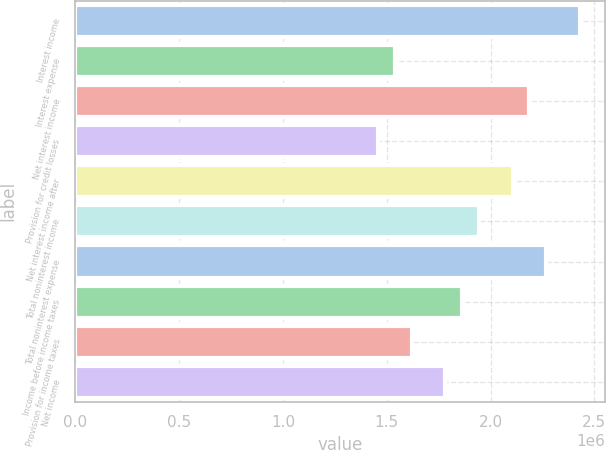Convert chart to OTSL. <chart><loc_0><loc_0><loc_500><loc_500><bar_chart><fcel>Interest income<fcel>Interest expense<fcel>Net interest income<fcel>Provision for credit losses<fcel>Net interest income after<fcel>Total noninterest income<fcel>Total noninterest expense<fcel>Income before income taxes<fcel>Provision for income taxes<fcel>Net income<nl><fcel>2.43043e+06<fcel>1.53927e+06<fcel>2.18739e+06<fcel>1.45826e+06<fcel>2.10637e+06<fcel>1.94434e+06<fcel>2.2684e+06<fcel>1.86333e+06<fcel>1.62029e+06<fcel>1.78231e+06<nl></chart> 